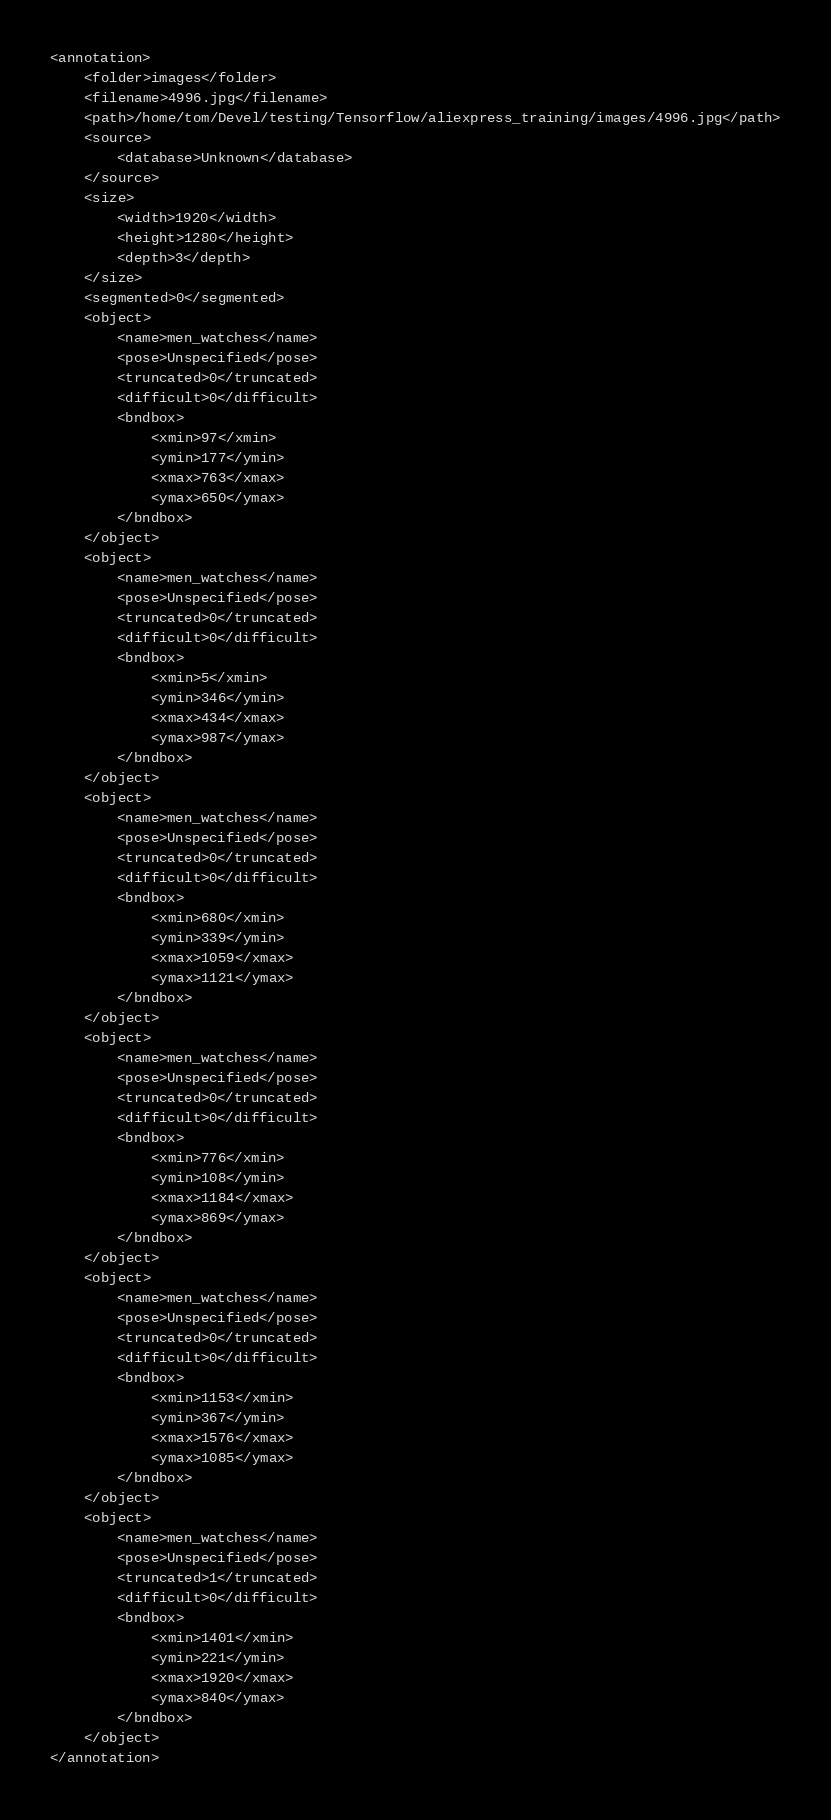<code> <loc_0><loc_0><loc_500><loc_500><_XML_><annotation>
	<folder>images</folder>
	<filename>4996.jpg</filename>
	<path>/home/tom/Devel/testing/Tensorflow/aliexpress_training/images/4996.jpg</path>
	<source>
		<database>Unknown</database>
	</source>
	<size>
		<width>1920</width>
		<height>1280</height>
		<depth>3</depth>
	</size>
	<segmented>0</segmented>
	<object>
		<name>men_watches</name>
		<pose>Unspecified</pose>
		<truncated>0</truncated>
		<difficult>0</difficult>
		<bndbox>
			<xmin>97</xmin>
			<ymin>177</ymin>
			<xmax>763</xmax>
			<ymax>650</ymax>
		</bndbox>
	</object>
	<object>
		<name>men_watches</name>
		<pose>Unspecified</pose>
		<truncated>0</truncated>
		<difficult>0</difficult>
		<bndbox>
			<xmin>5</xmin>
			<ymin>346</ymin>
			<xmax>434</xmax>
			<ymax>987</ymax>
		</bndbox>
	</object>
	<object>
		<name>men_watches</name>
		<pose>Unspecified</pose>
		<truncated>0</truncated>
		<difficult>0</difficult>
		<bndbox>
			<xmin>680</xmin>
			<ymin>339</ymin>
			<xmax>1059</xmax>
			<ymax>1121</ymax>
		</bndbox>
	</object>
	<object>
		<name>men_watches</name>
		<pose>Unspecified</pose>
		<truncated>0</truncated>
		<difficult>0</difficult>
		<bndbox>
			<xmin>776</xmin>
			<ymin>108</ymin>
			<xmax>1184</xmax>
			<ymax>869</ymax>
		</bndbox>
	</object>
	<object>
		<name>men_watches</name>
		<pose>Unspecified</pose>
		<truncated>0</truncated>
		<difficult>0</difficult>
		<bndbox>
			<xmin>1153</xmin>
			<ymin>367</ymin>
			<xmax>1576</xmax>
			<ymax>1085</ymax>
		</bndbox>
	</object>
	<object>
		<name>men_watches</name>
		<pose>Unspecified</pose>
		<truncated>1</truncated>
		<difficult>0</difficult>
		<bndbox>
			<xmin>1401</xmin>
			<ymin>221</ymin>
			<xmax>1920</xmax>
			<ymax>840</ymax>
		</bndbox>
	</object>
</annotation>
</code> 